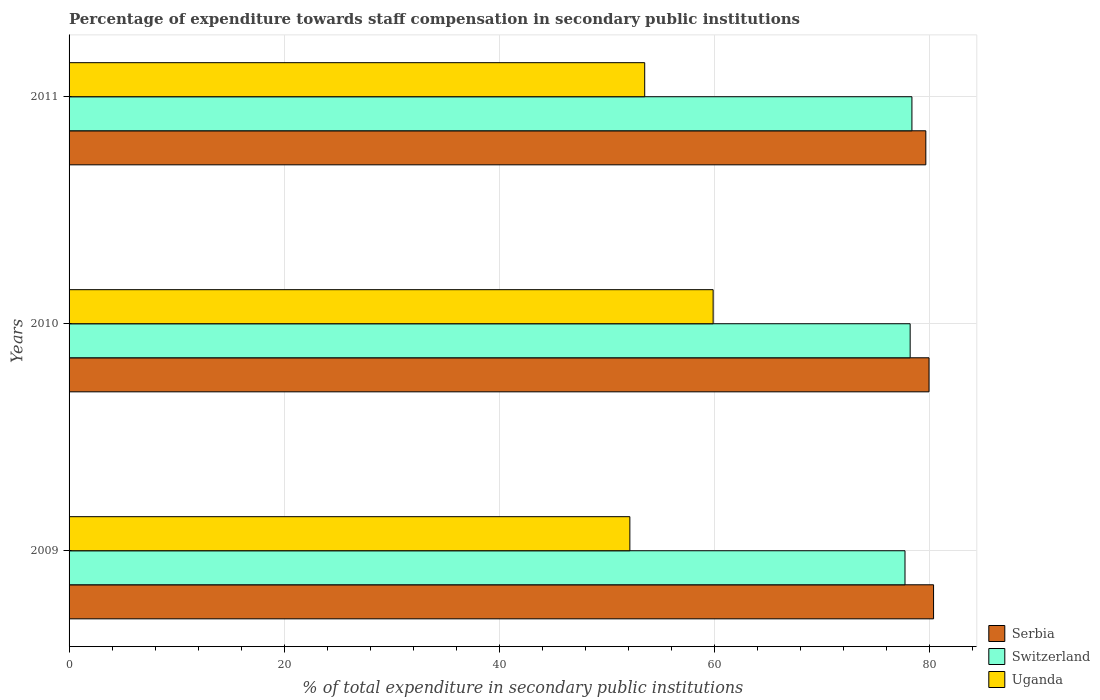How many different coloured bars are there?
Keep it short and to the point. 3. How many groups of bars are there?
Your answer should be very brief. 3. How many bars are there on the 3rd tick from the top?
Offer a very short reply. 3. How many bars are there on the 2nd tick from the bottom?
Provide a short and direct response. 3. What is the percentage of expenditure towards staff compensation in Switzerland in 2010?
Make the answer very short. 78.22. Across all years, what is the maximum percentage of expenditure towards staff compensation in Uganda?
Provide a succinct answer. 59.9. Across all years, what is the minimum percentage of expenditure towards staff compensation in Serbia?
Provide a short and direct response. 79.67. In which year was the percentage of expenditure towards staff compensation in Serbia minimum?
Your answer should be very brief. 2011. What is the total percentage of expenditure towards staff compensation in Switzerland in the graph?
Your answer should be very brief. 234.34. What is the difference between the percentage of expenditure towards staff compensation in Serbia in 2010 and that in 2011?
Your answer should be very brief. 0.3. What is the difference between the percentage of expenditure towards staff compensation in Serbia in 2010 and the percentage of expenditure towards staff compensation in Uganda in 2011?
Make the answer very short. 26.44. What is the average percentage of expenditure towards staff compensation in Uganda per year?
Keep it short and to the point. 55.19. In the year 2010, what is the difference between the percentage of expenditure towards staff compensation in Switzerland and percentage of expenditure towards staff compensation in Serbia?
Your response must be concise. -1.75. What is the ratio of the percentage of expenditure towards staff compensation in Serbia in 2009 to that in 2011?
Provide a succinct answer. 1.01. Is the difference between the percentage of expenditure towards staff compensation in Switzerland in 2009 and 2010 greater than the difference between the percentage of expenditure towards staff compensation in Serbia in 2009 and 2010?
Give a very brief answer. No. What is the difference between the highest and the second highest percentage of expenditure towards staff compensation in Uganda?
Give a very brief answer. 6.36. What is the difference between the highest and the lowest percentage of expenditure towards staff compensation in Serbia?
Provide a succinct answer. 0.72. In how many years, is the percentage of expenditure towards staff compensation in Serbia greater than the average percentage of expenditure towards staff compensation in Serbia taken over all years?
Your answer should be compact. 1. Is the sum of the percentage of expenditure towards staff compensation in Serbia in 2010 and 2011 greater than the maximum percentage of expenditure towards staff compensation in Uganda across all years?
Give a very brief answer. Yes. What does the 2nd bar from the top in 2010 represents?
Offer a terse response. Switzerland. What does the 1st bar from the bottom in 2009 represents?
Offer a terse response. Serbia. How many bars are there?
Provide a succinct answer. 9. How many years are there in the graph?
Offer a terse response. 3. What is the difference between two consecutive major ticks on the X-axis?
Offer a very short reply. 20. Does the graph contain grids?
Your answer should be very brief. Yes. Where does the legend appear in the graph?
Ensure brevity in your answer.  Bottom right. What is the title of the graph?
Your answer should be compact. Percentage of expenditure towards staff compensation in secondary public institutions. What is the label or title of the X-axis?
Your answer should be compact. % of total expenditure in secondary public institutions. What is the label or title of the Y-axis?
Ensure brevity in your answer.  Years. What is the % of total expenditure in secondary public institutions of Serbia in 2009?
Your answer should be very brief. 80.39. What is the % of total expenditure in secondary public institutions in Switzerland in 2009?
Make the answer very short. 77.74. What is the % of total expenditure in secondary public institutions in Uganda in 2009?
Ensure brevity in your answer.  52.15. What is the % of total expenditure in secondary public institutions of Serbia in 2010?
Provide a succinct answer. 79.97. What is the % of total expenditure in secondary public institutions of Switzerland in 2010?
Make the answer very short. 78.22. What is the % of total expenditure in secondary public institutions in Uganda in 2010?
Give a very brief answer. 59.9. What is the % of total expenditure in secondary public institutions of Serbia in 2011?
Your answer should be compact. 79.67. What is the % of total expenditure in secondary public institutions in Switzerland in 2011?
Your answer should be very brief. 78.38. What is the % of total expenditure in secondary public institutions in Uganda in 2011?
Offer a terse response. 53.53. Across all years, what is the maximum % of total expenditure in secondary public institutions of Serbia?
Make the answer very short. 80.39. Across all years, what is the maximum % of total expenditure in secondary public institutions in Switzerland?
Your answer should be compact. 78.38. Across all years, what is the maximum % of total expenditure in secondary public institutions in Uganda?
Your response must be concise. 59.9. Across all years, what is the minimum % of total expenditure in secondary public institutions of Serbia?
Keep it short and to the point. 79.67. Across all years, what is the minimum % of total expenditure in secondary public institutions of Switzerland?
Offer a very short reply. 77.74. Across all years, what is the minimum % of total expenditure in secondary public institutions in Uganda?
Provide a succinct answer. 52.15. What is the total % of total expenditure in secondary public institutions in Serbia in the graph?
Your answer should be compact. 240.04. What is the total % of total expenditure in secondary public institutions of Switzerland in the graph?
Your answer should be compact. 234.34. What is the total % of total expenditure in secondary public institutions of Uganda in the graph?
Offer a very short reply. 165.58. What is the difference between the % of total expenditure in secondary public institutions in Serbia in 2009 and that in 2010?
Offer a terse response. 0.42. What is the difference between the % of total expenditure in secondary public institutions of Switzerland in 2009 and that in 2010?
Give a very brief answer. -0.48. What is the difference between the % of total expenditure in secondary public institutions of Uganda in 2009 and that in 2010?
Offer a very short reply. -7.75. What is the difference between the % of total expenditure in secondary public institutions of Serbia in 2009 and that in 2011?
Your answer should be compact. 0.72. What is the difference between the % of total expenditure in secondary public institutions of Switzerland in 2009 and that in 2011?
Your response must be concise. -0.64. What is the difference between the % of total expenditure in secondary public institutions in Uganda in 2009 and that in 2011?
Make the answer very short. -1.38. What is the difference between the % of total expenditure in secondary public institutions in Serbia in 2010 and that in 2011?
Provide a succinct answer. 0.3. What is the difference between the % of total expenditure in secondary public institutions of Switzerland in 2010 and that in 2011?
Your answer should be very brief. -0.16. What is the difference between the % of total expenditure in secondary public institutions in Uganda in 2010 and that in 2011?
Your answer should be compact. 6.36. What is the difference between the % of total expenditure in secondary public institutions of Serbia in 2009 and the % of total expenditure in secondary public institutions of Switzerland in 2010?
Give a very brief answer. 2.18. What is the difference between the % of total expenditure in secondary public institutions in Serbia in 2009 and the % of total expenditure in secondary public institutions in Uganda in 2010?
Your answer should be compact. 20.5. What is the difference between the % of total expenditure in secondary public institutions of Switzerland in 2009 and the % of total expenditure in secondary public institutions of Uganda in 2010?
Your response must be concise. 17.84. What is the difference between the % of total expenditure in secondary public institutions in Serbia in 2009 and the % of total expenditure in secondary public institutions in Switzerland in 2011?
Give a very brief answer. 2.01. What is the difference between the % of total expenditure in secondary public institutions in Serbia in 2009 and the % of total expenditure in secondary public institutions in Uganda in 2011?
Your response must be concise. 26.86. What is the difference between the % of total expenditure in secondary public institutions in Switzerland in 2009 and the % of total expenditure in secondary public institutions in Uganda in 2011?
Your answer should be very brief. 24.21. What is the difference between the % of total expenditure in secondary public institutions in Serbia in 2010 and the % of total expenditure in secondary public institutions in Switzerland in 2011?
Your response must be concise. 1.59. What is the difference between the % of total expenditure in secondary public institutions of Serbia in 2010 and the % of total expenditure in secondary public institutions of Uganda in 2011?
Ensure brevity in your answer.  26.44. What is the difference between the % of total expenditure in secondary public institutions in Switzerland in 2010 and the % of total expenditure in secondary public institutions in Uganda in 2011?
Offer a terse response. 24.69. What is the average % of total expenditure in secondary public institutions of Serbia per year?
Your answer should be compact. 80.01. What is the average % of total expenditure in secondary public institutions in Switzerland per year?
Offer a terse response. 78.11. What is the average % of total expenditure in secondary public institutions in Uganda per year?
Provide a succinct answer. 55.19. In the year 2009, what is the difference between the % of total expenditure in secondary public institutions in Serbia and % of total expenditure in secondary public institutions in Switzerland?
Offer a terse response. 2.66. In the year 2009, what is the difference between the % of total expenditure in secondary public institutions in Serbia and % of total expenditure in secondary public institutions in Uganda?
Your answer should be compact. 28.24. In the year 2009, what is the difference between the % of total expenditure in secondary public institutions of Switzerland and % of total expenditure in secondary public institutions of Uganda?
Your answer should be very brief. 25.59. In the year 2010, what is the difference between the % of total expenditure in secondary public institutions in Serbia and % of total expenditure in secondary public institutions in Switzerland?
Provide a succinct answer. 1.75. In the year 2010, what is the difference between the % of total expenditure in secondary public institutions of Serbia and % of total expenditure in secondary public institutions of Uganda?
Keep it short and to the point. 20.08. In the year 2010, what is the difference between the % of total expenditure in secondary public institutions of Switzerland and % of total expenditure in secondary public institutions of Uganda?
Give a very brief answer. 18.32. In the year 2011, what is the difference between the % of total expenditure in secondary public institutions in Serbia and % of total expenditure in secondary public institutions in Switzerland?
Provide a short and direct response. 1.29. In the year 2011, what is the difference between the % of total expenditure in secondary public institutions of Serbia and % of total expenditure in secondary public institutions of Uganda?
Give a very brief answer. 26.14. In the year 2011, what is the difference between the % of total expenditure in secondary public institutions in Switzerland and % of total expenditure in secondary public institutions in Uganda?
Offer a very short reply. 24.85. What is the ratio of the % of total expenditure in secondary public institutions of Switzerland in 2009 to that in 2010?
Keep it short and to the point. 0.99. What is the ratio of the % of total expenditure in secondary public institutions in Uganda in 2009 to that in 2010?
Make the answer very short. 0.87. What is the ratio of the % of total expenditure in secondary public institutions in Serbia in 2009 to that in 2011?
Provide a succinct answer. 1.01. What is the ratio of the % of total expenditure in secondary public institutions in Switzerland in 2009 to that in 2011?
Keep it short and to the point. 0.99. What is the ratio of the % of total expenditure in secondary public institutions in Uganda in 2009 to that in 2011?
Ensure brevity in your answer.  0.97. What is the ratio of the % of total expenditure in secondary public institutions in Uganda in 2010 to that in 2011?
Your answer should be compact. 1.12. What is the difference between the highest and the second highest % of total expenditure in secondary public institutions of Serbia?
Give a very brief answer. 0.42. What is the difference between the highest and the second highest % of total expenditure in secondary public institutions of Switzerland?
Provide a short and direct response. 0.16. What is the difference between the highest and the second highest % of total expenditure in secondary public institutions of Uganda?
Provide a succinct answer. 6.36. What is the difference between the highest and the lowest % of total expenditure in secondary public institutions of Serbia?
Give a very brief answer. 0.72. What is the difference between the highest and the lowest % of total expenditure in secondary public institutions of Switzerland?
Your answer should be very brief. 0.64. What is the difference between the highest and the lowest % of total expenditure in secondary public institutions of Uganda?
Provide a succinct answer. 7.75. 